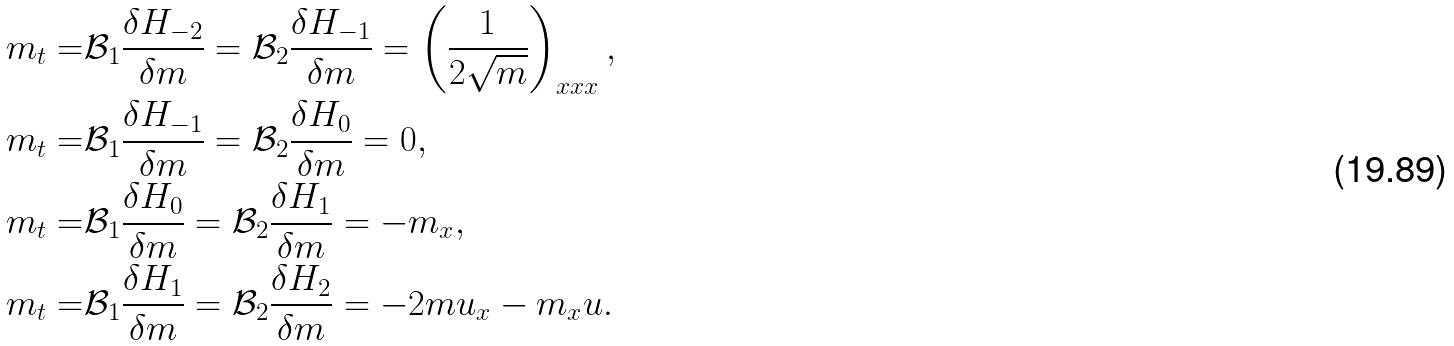Convert formula to latex. <formula><loc_0><loc_0><loc_500><loc_500>m _ { t } = & \mathcal { B } _ { 1 } \frac { \delta H _ { - 2 } } { \delta m } = \mathcal { B } _ { 2 } \frac { \delta H _ { - 1 } } { \delta m } = \left ( \frac { 1 } { 2 \sqrt { m } } \right ) _ { x x x } , \\ m _ { t } = & \mathcal { B } _ { 1 } \frac { \delta H _ { - 1 } } { \delta m } = \mathcal { B } _ { 2 } \frac { \delta H _ { 0 } } { \delta m } = 0 , \\ m _ { t } = & \mathcal { B } _ { 1 } \frac { \delta H _ { 0 } } { \delta m } = \mathcal { B } _ { 2 } \frac { \delta H _ { 1 } } { \delta m } = - m _ { x } , \\ m _ { t } = & \mathcal { B } _ { 1 } \frac { \delta H _ { 1 } } { \delta m } = \mathcal { B } _ { 2 } \frac { \delta H _ { 2 } } { \delta m } = - 2 m u _ { x } - m _ { x } u .</formula> 